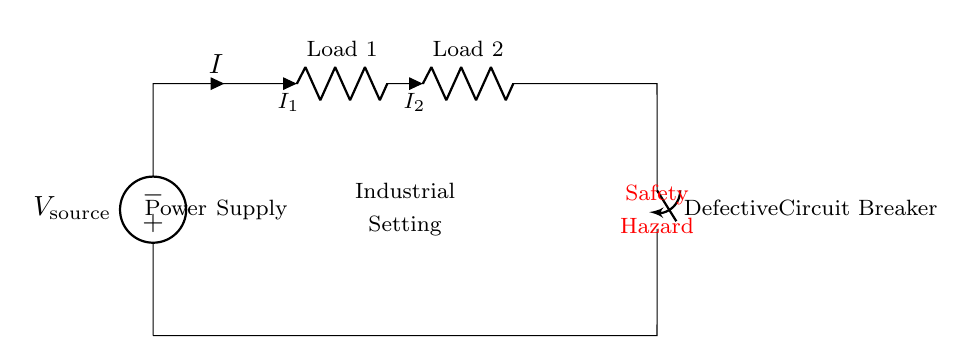What is the voltage source in the circuit? The voltage source is labeled as V source, indicating the input electrical potential supplied to the circuit.
Answer: V source How many loads are present in the circuit? The circuit has two components labeled as Load 1 and Load 2, both classified as resistors in the series.
Answer: Two What is indicated by the component labeled "Defective Circuit Breaker"? This component suggests a failure in the circuit that poses a safety risk, preventing proper circuit operation and potentially leading to hazards.
Answer: Safety Hazard What is the current flow direction in the series circuit? The current is indicated by the arrow labeled I flowing through the circuit, which suggests a single path without branching.
Answer: Single direction What could be the consequence of having a defective circuit breaker? A defective circuit breaker may lead to overload or circuit failure, exposing the system to risks like short circuits or fires.
Answer: Safety Hazard What is the relationship between the current flowing through Load 1 and Load 2? In a series circuit, the current remains constant; hence the current flowing through Load 1 (I1) equals the current flowing through Load 2 (I2).
Answer: Constant What does the notation “i=_” next to the loads signify? This notation represents the current flowing through each load, where I1 and I2 show that current direction and magnitude is being monitored at each component.
Answer: Current indicators 